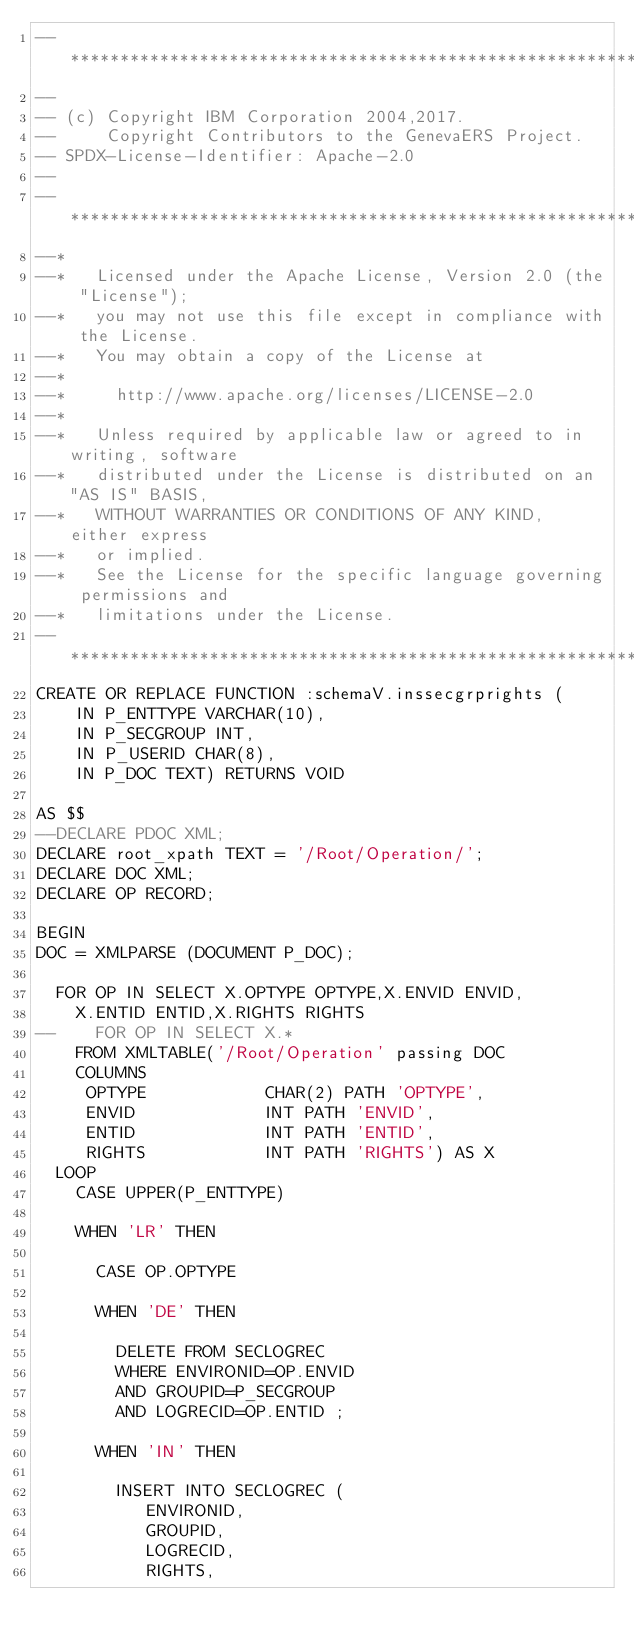<code> <loc_0><loc_0><loc_500><loc_500><_SQL_>--****************************************************************
--
-- (c) Copyright IBM Corporation 2004,2017.  
--     Copyright Contributors to the GenevaERS Project.
-- SPDX-License-Identifier: Apache-2.0
--
--***********************************************************************
--*                                                                           
--*   Licensed under the Apache License, Version 2.0 (the "License");         
--*   you may not use this file except in compliance with the License.        
--*   You may obtain a copy of the License at                                 
--*                                                                           
--*     http://www.apache.org/licenses/LICENSE-2.0                            
--*                                                                           
--*   Unless required by applicable law or agreed to in writing, software     
--*   distributed under the License is distributed on an "AS IS" BASIS,       
--*   WITHOUT WARRANTIES OR CONDITIONS OF ANY KIND, either express 
--*   or implied.
--*   See the License for the specific language governing permissions and     
--*   limitations under the License.                                          
--***********************************************************************
CREATE OR REPLACE FUNCTION :schemaV.inssecgrprights ( 
    IN P_ENTTYPE VARCHAR(10),
    IN P_SECGROUP INT,
    IN P_USERID CHAR(8),
    IN P_DOC TEXT) RETURNS VOID

AS $$ 
--DECLARE PDOC XML;
DECLARE root_xpath TEXT = '/Root/Operation/';
DECLARE DOC XML;
DECLARE OP RECORD;

BEGIN
DOC = XMLPARSE (DOCUMENT P_DOC);

  FOR OP IN SELECT X.OPTYPE OPTYPE,X.ENVID ENVID,
    X.ENTID ENTID,X.RIGHTS RIGHTS
--    FOR OP IN SELECT X.*
    FROM XMLTABLE('/Root/Operation' passing DOC 
    COLUMNS
     OPTYPE            CHAR(2) PATH 'OPTYPE',
     ENVID             INT PATH 'ENVID', 
     ENTID             INT PATH 'ENTID',
     RIGHTS            INT PATH 'RIGHTS') AS X
  LOOP    
    CASE UPPER(P_ENTTYPE)

    WHEN 'LR' THEN

      CASE OP.OPTYPE

      WHEN 'DE' THEN

        DELETE FROM SECLOGREC
        WHERE ENVIRONID=OP.ENVID
        AND GROUPID=P_SECGROUP
        AND LOGRECID=OP.ENTID ;

      WHEN 'IN' THEN

        INSERT INTO SECLOGREC (
           ENVIRONID,
           GROUPID,
           LOGRECID,
           RIGHTS,</code> 